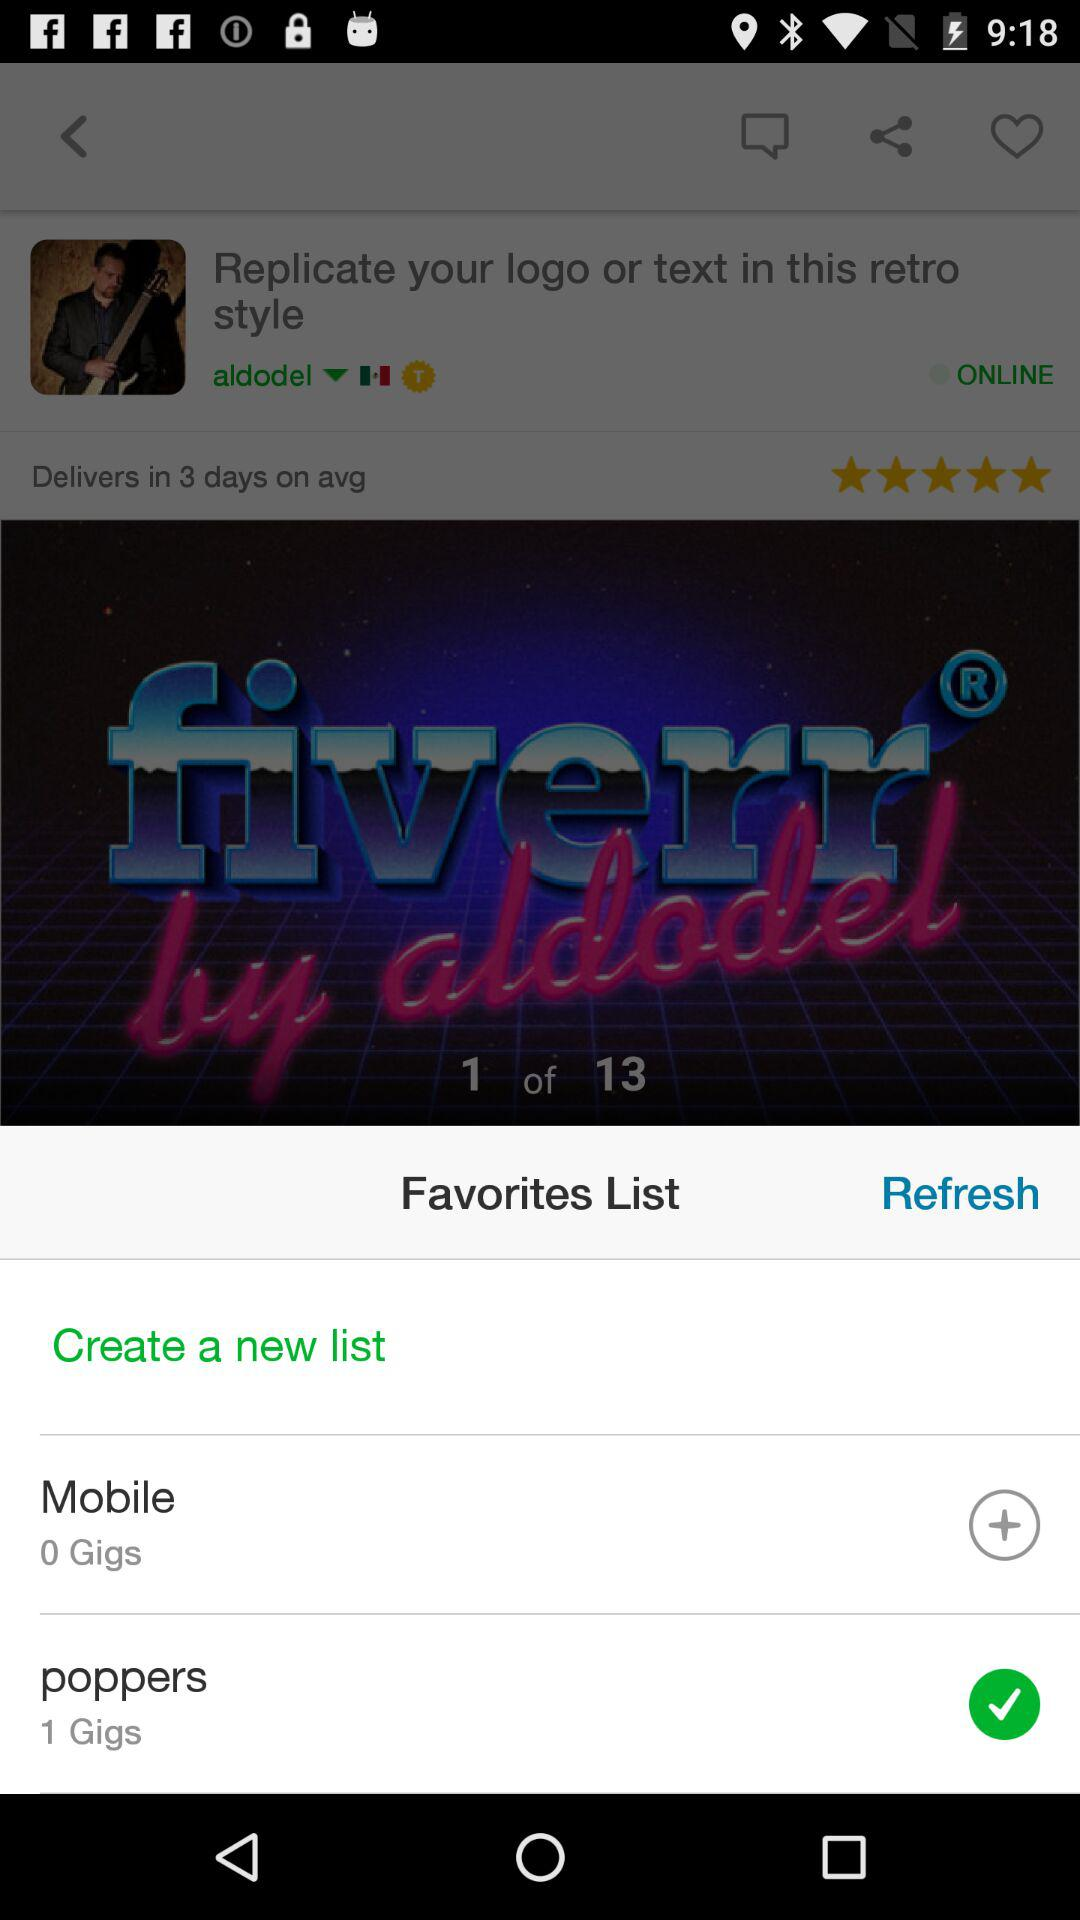What is the status of "poppers"? The status is "on". 